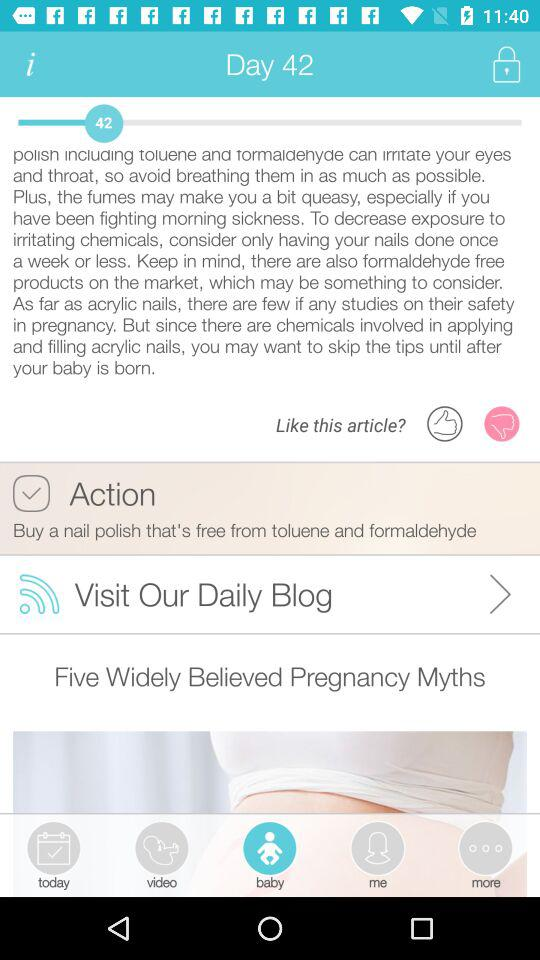What is the status of "Action"? The status is "on". 